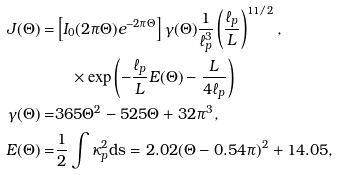Convert formula to latex. <formula><loc_0><loc_0><loc_500><loc_500>J ( \Theta ) = & \left [ I _ { 0 } ( 2 \pi \Theta ) e ^ { - 2 \pi \Theta } \right ] \gamma ( \Theta ) \frac { 1 } { \ell _ { p } ^ { 3 } } \left ( \frac { \ell _ { p } } { L } \right ) ^ { 1 1 / 2 } , \\ & \quad \times \exp \left ( - \frac { \ell _ { p } } { L } E ( \Theta ) - \frac { L } { 4 \ell _ { p } } \right ) \\ \gamma ( \Theta ) = & 3 6 5 \Theta ^ { 2 } - 5 2 5 \Theta + 3 2 \pi ^ { 3 } , \\ E ( \Theta ) = & \frac { 1 } { 2 } \int \kappa _ { p } ^ { 2 } \text {ds} = 2 . 0 2 ( \Theta - 0 . 5 4 \pi ) ^ { 2 } + 1 4 . 0 5 ,</formula> 